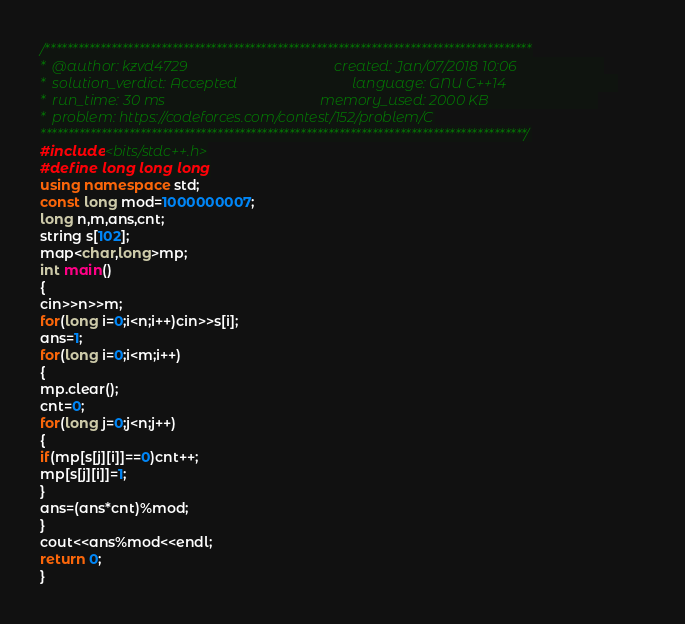<code> <loc_0><loc_0><loc_500><loc_500><_C++_>/****************************************************************************************
*  @author: kzvd4729                                         created: Jan/07/2018 10:06                        
*  solution_verdict: Accepted                                language: GNU C++14                               
*  run_time: 30 ms                                           memory_used: 2000 KB                              
*  problem: https://codeforces.com/contest/152/problem/C
****************************************************************************************/
#include<bits/stdc++.h>
#define long long long
using namespace std;
const long mod=1000000007;
long n,m,ans,cnt;
string s[102];
map<char,long>mp;
int main()
{
cin>>n>>m;
for(long i=0;i<n;i++)cin>>s[i];
ans=1;
for(long i=0;i<m;i++)
{
mp.clear();
cnt=0;
for(long j=0;j<n;j++)
{
if(mp[s[j][i]]==0)cnt++;
mp[s[j][i]]=1;
}
ans=(ans*cnt)%mod;
}
cout<<ans%mod<<endl;
return 0;
}</code> 